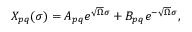<formula> <loc_0><loc_0><loc_500><loc_500>\begin{array} { l c r } { { X _ { p q } ( \sigma ) = A _ { p q } e ^ { \sqrt { \Omega } \sigma } + B _ { p q } e ^ { - \sqrt { \Omega } \sigma } , } } \end{array}</formula> 